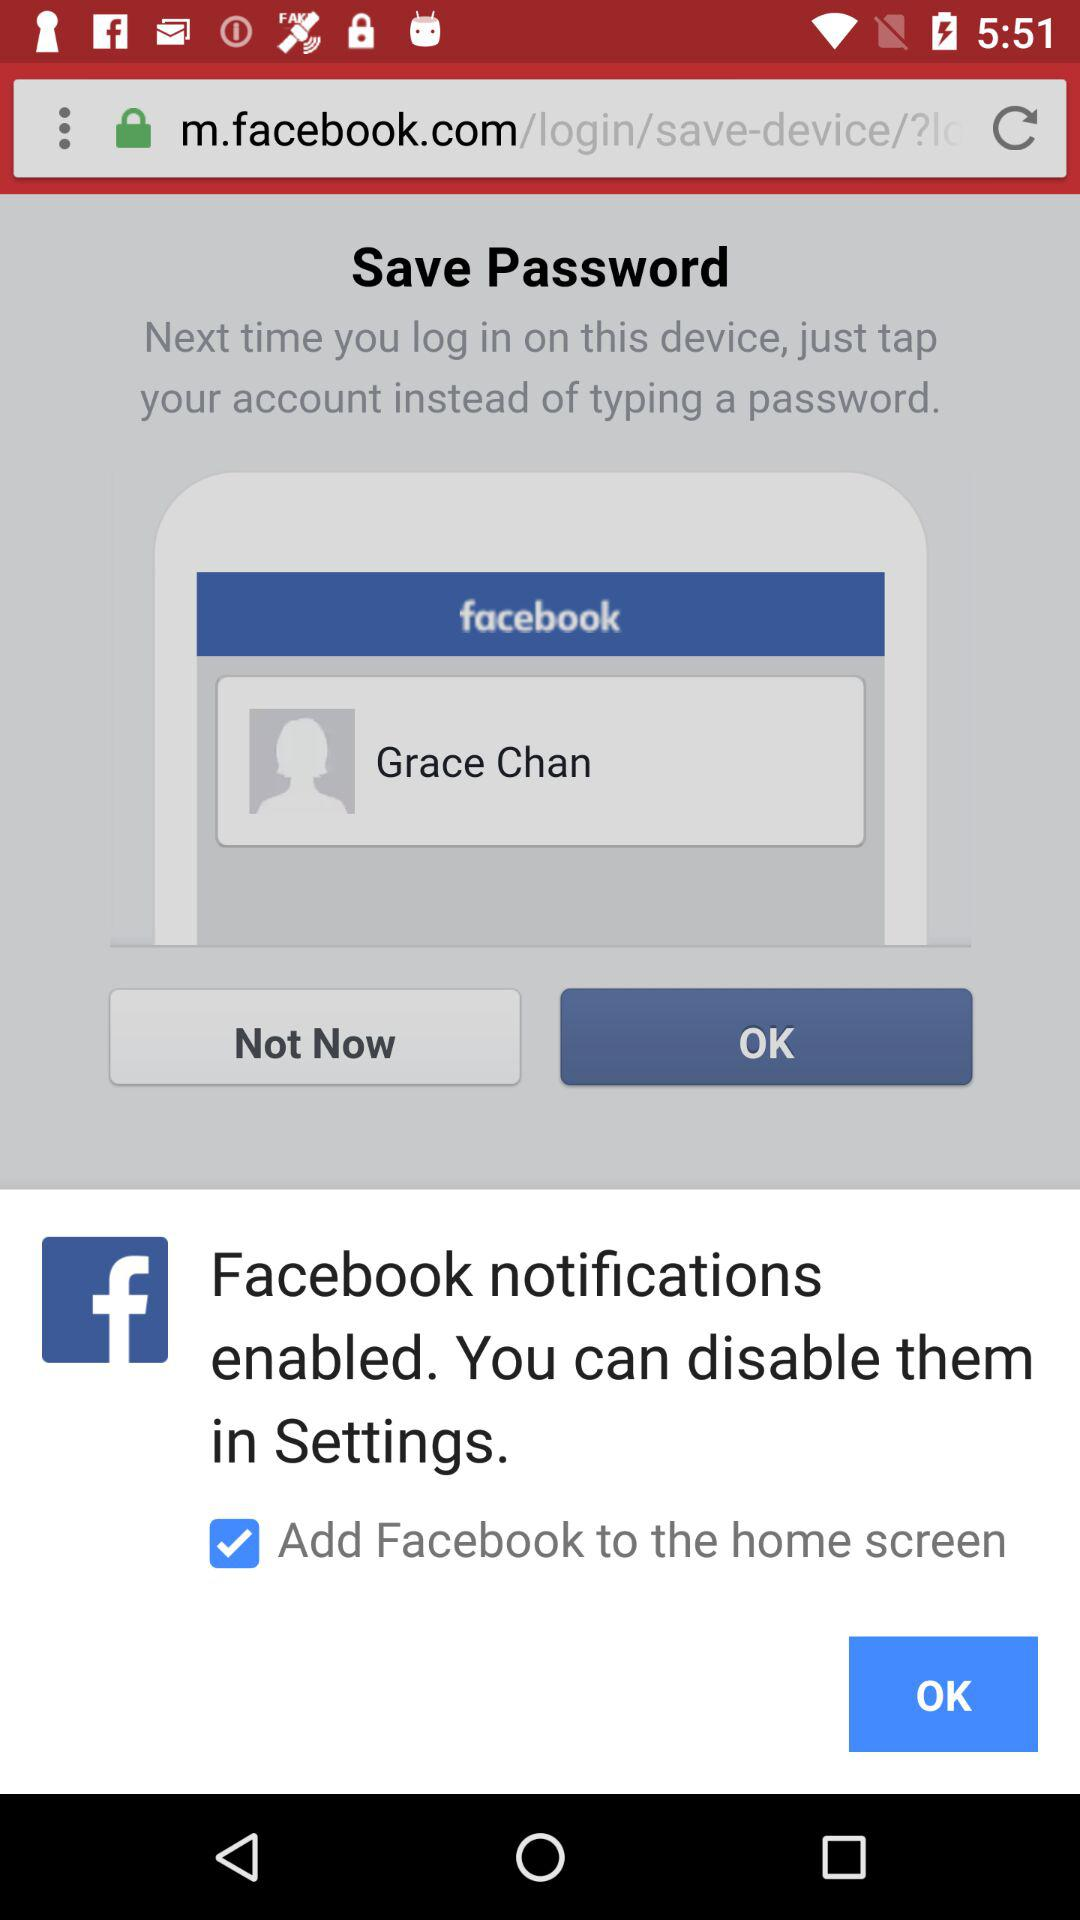Is the password saved?
When the provided information is insufficient, respond with <no answer>. <no answer> 